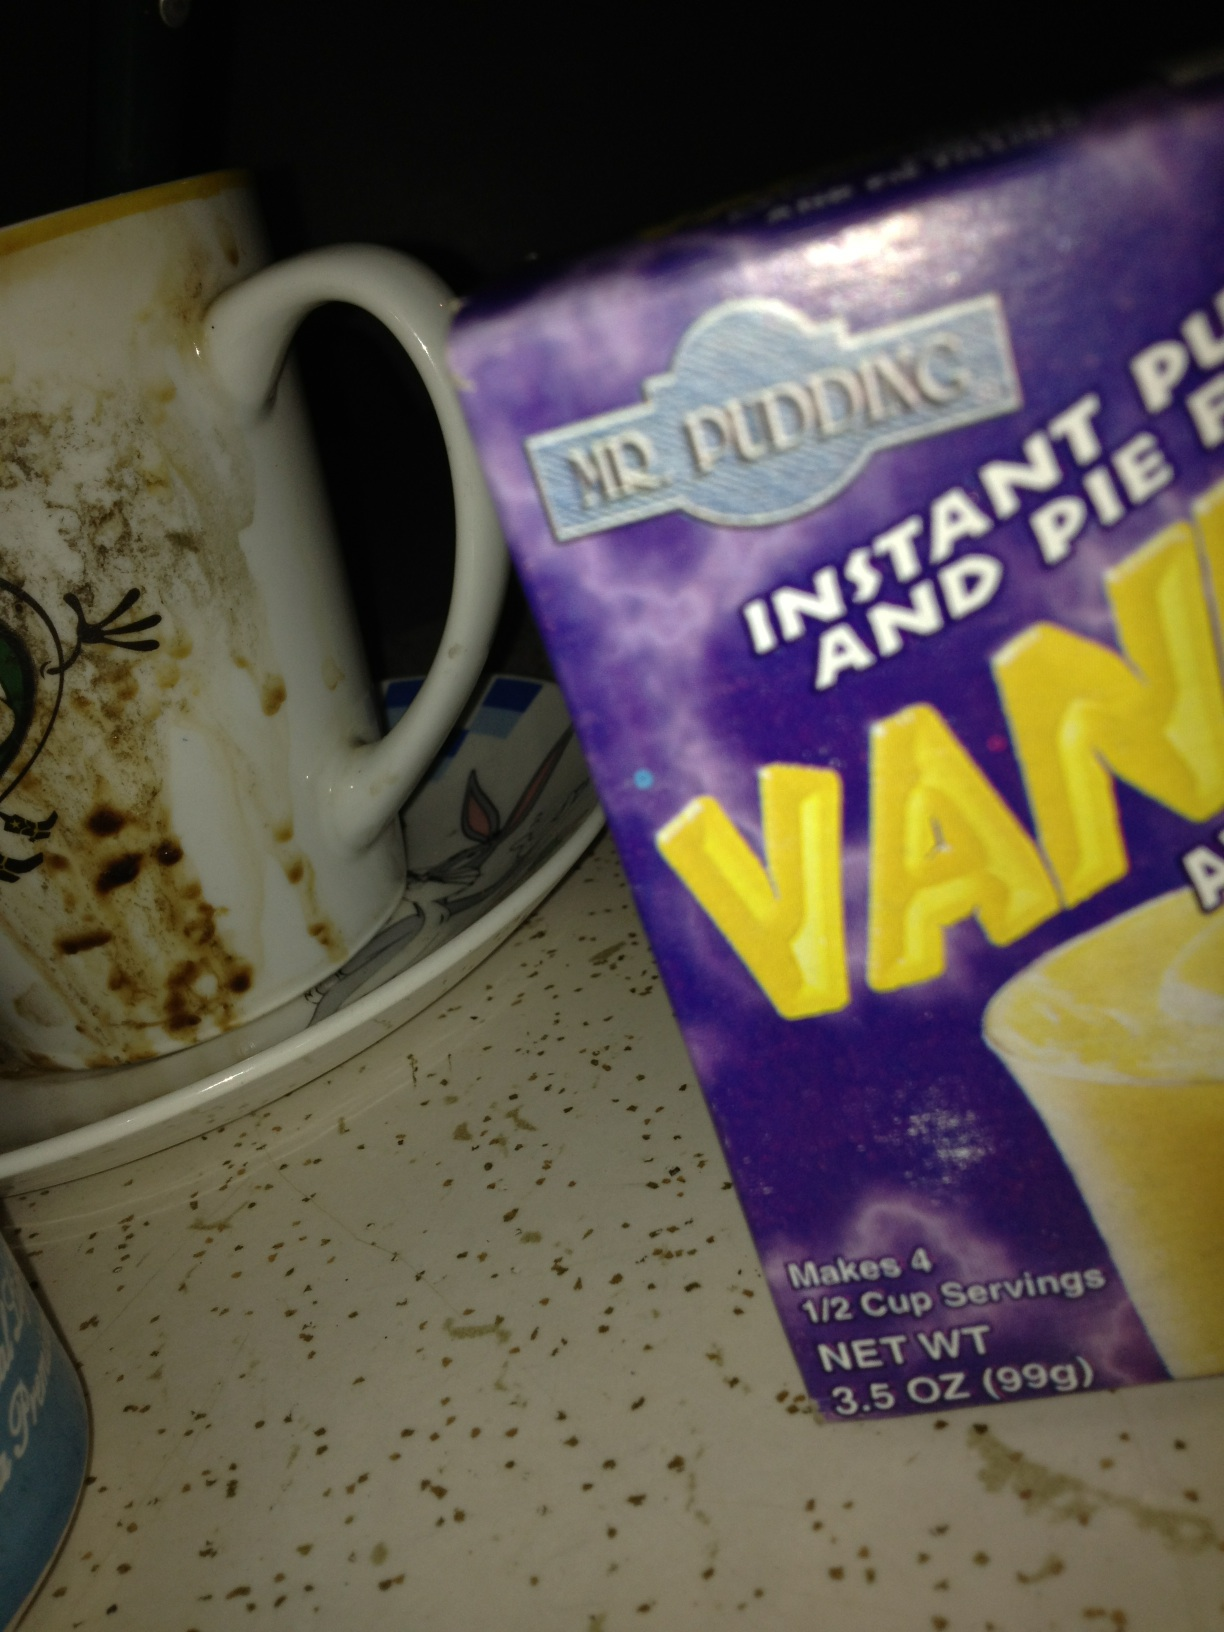What other items can I see in this picture? Besides the pudding mix, there's a visibly dirty coffee mug on the left. It appears that the area the items are in, possibly a kitchen shelf or cupboard, is in need of tidying and cleaning. 